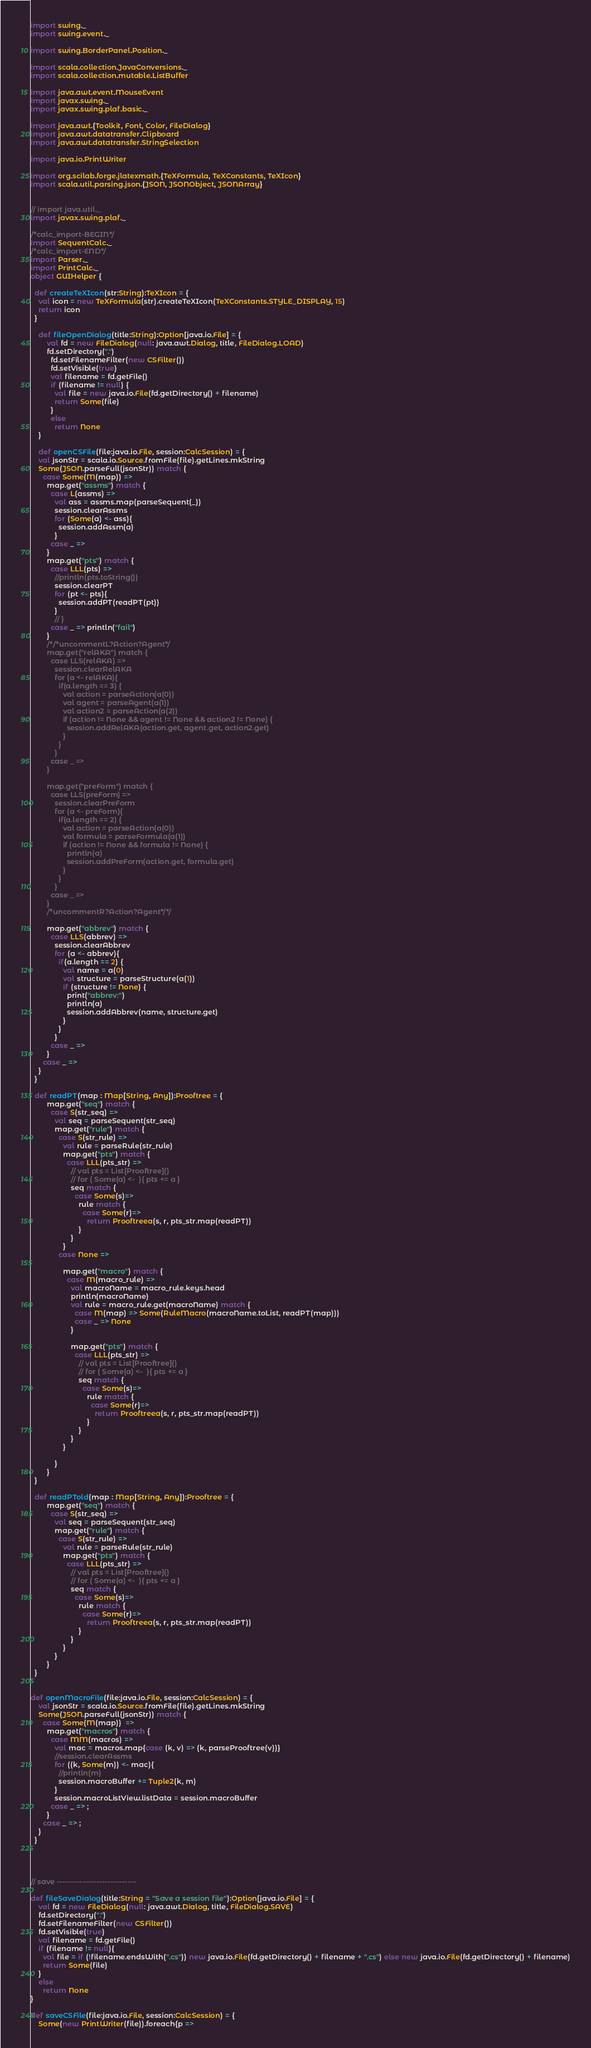<code> <loc_0><loc_0><loc_500><loc_500><_Scala_>import swing._
import swing.event._

import swing.BorderPanel.Position._

import scala.collection.JavaConversions._
import scala.collection.mutable.ListBuffer

import java.awt.event.MouseEvent
import javax.swing._
import javax.swing.plaf.basic._

import java.awt.{Toolkit, Font, Color, FileDialog}
import java.awt.datatransfer.Clipboard
import java.awt.datatransfer.StringSelection

import java.io.PrintWriter

import org.scilab.forge.jlatexmath.{TeXFormula, TeXConstants, TeXIcon}
import scala.util.parsing.json.{JSON, JSONObject, JSONArray}


// import java.util._
import javax.swing.plaf._

/*calc_import-BEGIN*/
import SequentCalc._
/*calc_import-END*/
import Parser._
import PrintCalc._
object GUIHelper {

  def createTeXIcon(str:String):TeXIcon = {
    val icon = new TeXFormula(str).createTeXIcon(TeXConstants.STYLE_DISPLAY, 15)
    return icon
  }

	def fileOpenDialog(title:String):Option[java.io.File] = {
		val fd = new FileDialog(null: java.awt.Dialog, title, FileDialog.LOAD)
        fd.setDirectory(".")
          fd.setFilenameFilter(new CSFilter())
          fd.setVisible(true)
          val filename = fd.getFile()
          if (filename != null) {
            val file = new java.io.File(fd.getDirectory() + filename)
            return Some(file)
          }
          else
            return None
	}

	def openCSFile(file:java.io.File, session:CalcSession) = {
    val jsonStr = scala.io.Source.fromFile(file).getLines.mkString
    Some(JSON.parseFull(jsonStr)) match {
      case Some(M(map)) =>
        map.get("assms") match {
          case L(assms) =>
            val ass = assms.map(parseSequent(_))
            session.clearAssms
            for (Some(a) <- ass){
              session.addAssm(a)
            }
          case _ => 
        }
        map.get("pts") match {
          case LLL(pts) =>
            //println(pts.toString())
            session.clearPT
            for (pt <- pts){
              session.addPT(readPT(pt))
            }
            // }
          case _ => println("fail")
        }
        /*/*uncommentL?Action?Agent*/
        map.get("relAKA") match {
          case LLS(relAKA) =>
            session.clearRelAKA
            for (a <- relAKA){
              if(a.length == 3) {
                val action = parseAction(a(0))
                val agent = parseAgent(a(1))
                val action2 = parseAction(a(2))
                if (action != None && agent != None && action2 != None) {
                  session.addRelAKA(action.get, agent.get, action2.get)
                }
              }
            }
          case _ => 
        }

        map.get("preForm") match {
          case LLS(preForm) =>
            session.clearPreForm
            for (a <- preForm){
              if(a.length == 2) {
                val action = parseAction(a(0))
                val formula = parseFormula(a(1))
                if (action != None && formula != None) {
                  println(a)
                  session.addPreForm(action.get, formula.get)
                }
              }
            }
          case _ => 
        }
        /*uncommentR?Action?Agent*/*/

        map.get("abbrev") match {
          case LLS(abbrev) =>
            session.clearAbbrev
            for (a <- abbrev){
              if(a.length == 2) {
                val name = a(0)
                val structure = parseStructure(a(1))
                if (structure != None) {
                  print("abbrev:")
                  println(a)
                  session.addAbbrev(name, structure.get)
                }
              }
            }
          case _ => 
        }
      case _ => 
    }
  }

  def readPT(map : Map[String, Any]):Prooftree = {
        map.get("seq") match {
          case S(str_seq) => 
            val seq = parseSequent(str_seq)
            map.get("rule") match {
              case S(str_rule) => 
                val rule = parseRule(str_rule)
                map.get("pts") match {
                  case LLL(pts_str) => 
                    // val pts = List[Prooftree]()
                    // for ( Some(a) <-  ){ pts += a }
                    seq match {
                      case Some(s)=>
                        rule match {
                          case Some(r)=> 
                            return Prooftreea(s, r, pts_str.map(readPT))
                        }
                    }
                }
              case None =>

                map.get("macro") match {
                  case M(macro_rule) => 
                    val macroName = macro_rule.keys.head
                    println(macroName)
                    val rule = macro_rule.get(macroName) match {
                      case M(map) => Some(RuleMacro(macroName.toList, readPT(map)))
                      case _ => None
                    }
                      
                    map.get("pts") match {
                      case LLL(pts_str) => 
                        // val pts = List[Prooftree]()
                        // for ( Some(a) <-  ){ pts += a }
                        seq match {
                          case Some(s)=>
                            rule match {
                              case Some(r)=> 
                                return Prooftreea(s, r, pts_str.map(readPT))
                            }
                        }
                    }
                }

            }
        }
  }

  def readPTold(map : Map[String, Any]):Prooftree = {
        map.get("seq") match {
          case S(str_seq) => 
            val seq = parseSequent(str_seq)
            map.get("rule") match {
              case S(str_rule) => 
                val rule = parseRule(str_rule)
                map.get("pts") match {
                  case LLL(pts_str) => 
                    // val pts = List[Prooftree]()
                    // for ( Some(a) <-  ){ pts += a }
                    seq match {
                      case Some(s)=>
                        rule match {
                          case Some(r)=> 
                            return Prooftreea(s, r, pts_str.map(readPT))
                        }
                    }
                }
            }
        }
  }


def openMacroFile(file:java.io.File, session:CalcSession) = {
    val jsonStr = scala.io.Source.fromFile(file).getLines.mkString
    Some(JSON.parseFull(jsonStr)) match {
      case Some(M(map))  =>
        map.get("macros") match {
          case MM(macros) =>
            val mac = macros.map{case (k, v) => (k, parseProoftree(v))}
            //session.clearAssms
            for ((k, Some(m)) <- mac){
              //println(m)
              session.macroBuffer += Tuple2(k, m)
            }
            session.macroListView.listData = session.macroBuffer
          case _ => ;
        }
      case _ => ;
    }
  }




// save ----------------------------

def fileSaveDialog(title:String = "Save a session file"):Option[java.io.File] = {
    val fd = new FileDialog(null: java.awt.Dialog, title, FileDialog.SAVE)
    fd.setDirectory(".")
    fd.setFilenameFilter(new CSFilter())
    fd.setVisible(true)
    val filename = fd.getFile()
    if (filename != null){
      val file = if (!filename.endsWith(".cs")) new java.io.File(fd.getDirectory() + filename + ".cs") else new java.io.File(fd.getDirectory() + filename)
      return Some(file)
    }
    else
      return None
}

def saveCSFile(file:java.io.File, session:CalcSession) = {  
    Some(new PrintWriter(file)).foreach{p =></code> 